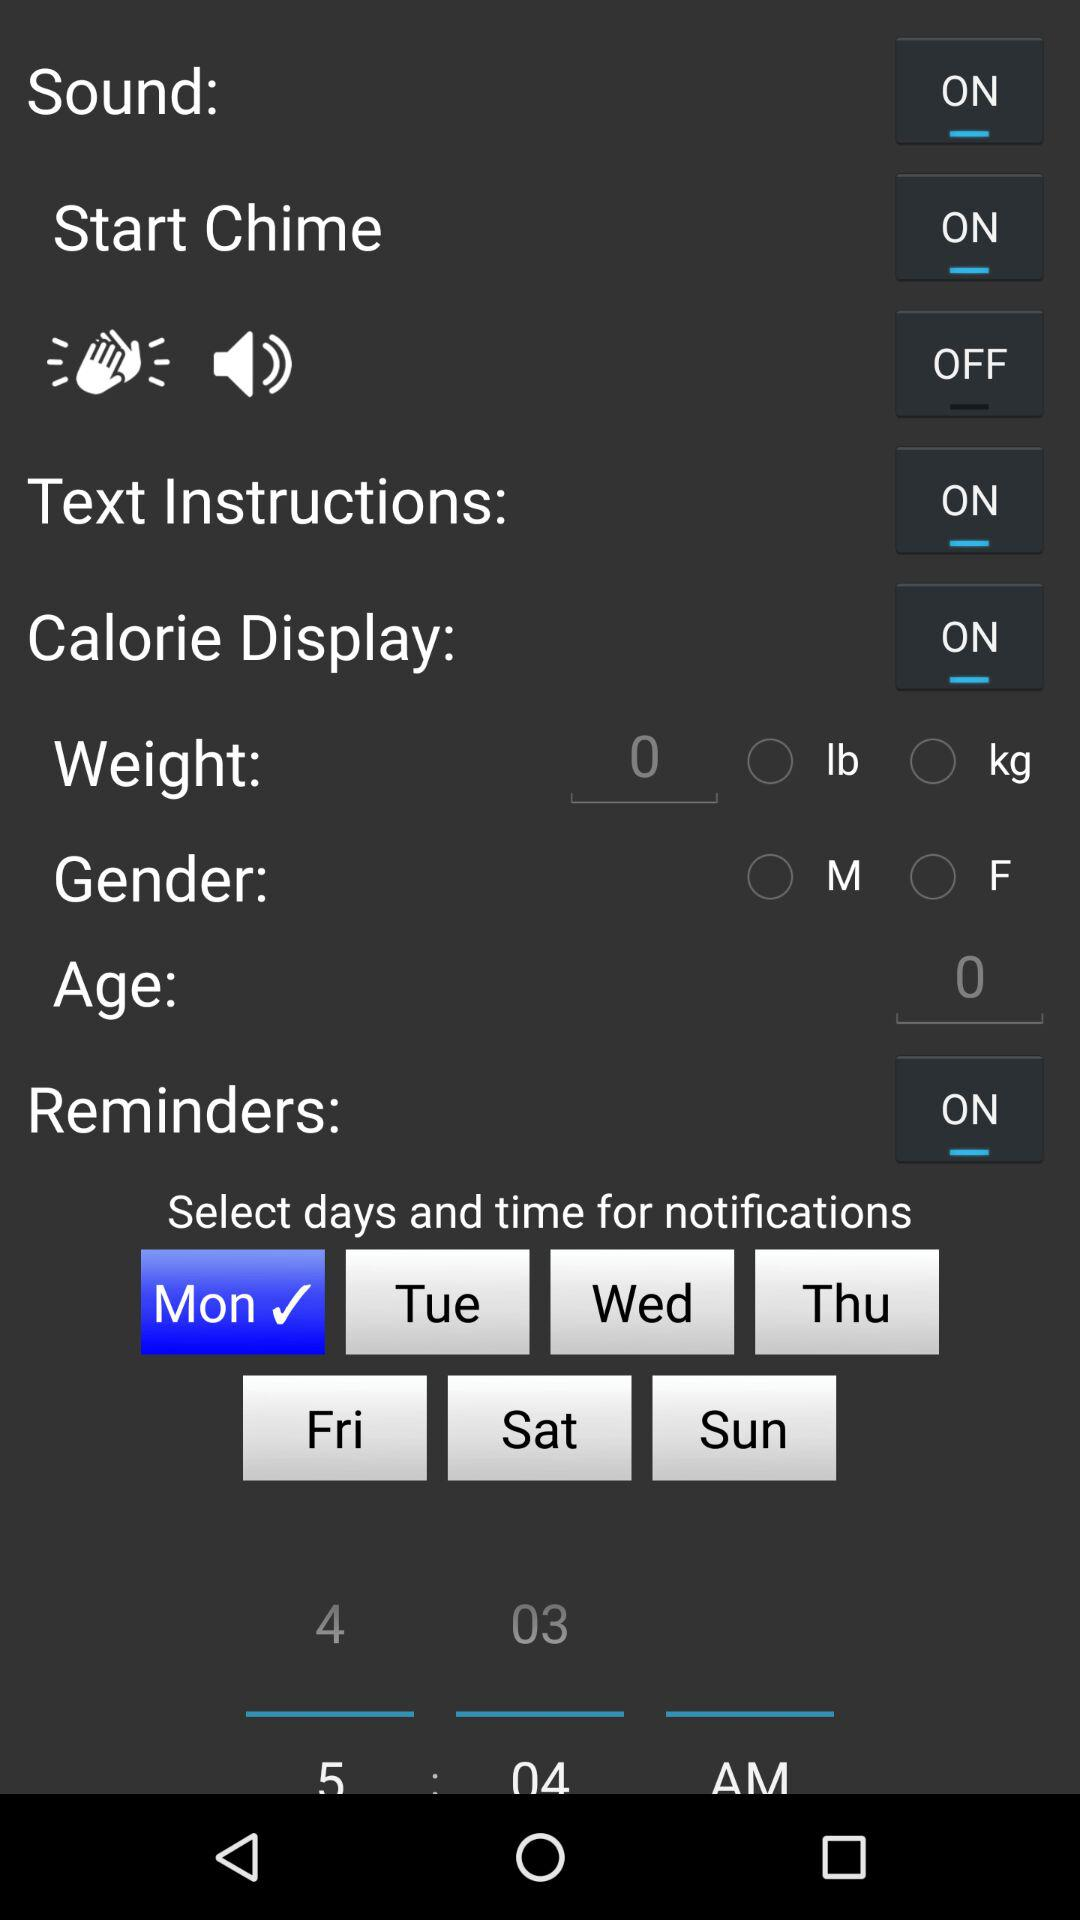Is the "Calorie Display" on or off? "Calorie Display" is "on". 